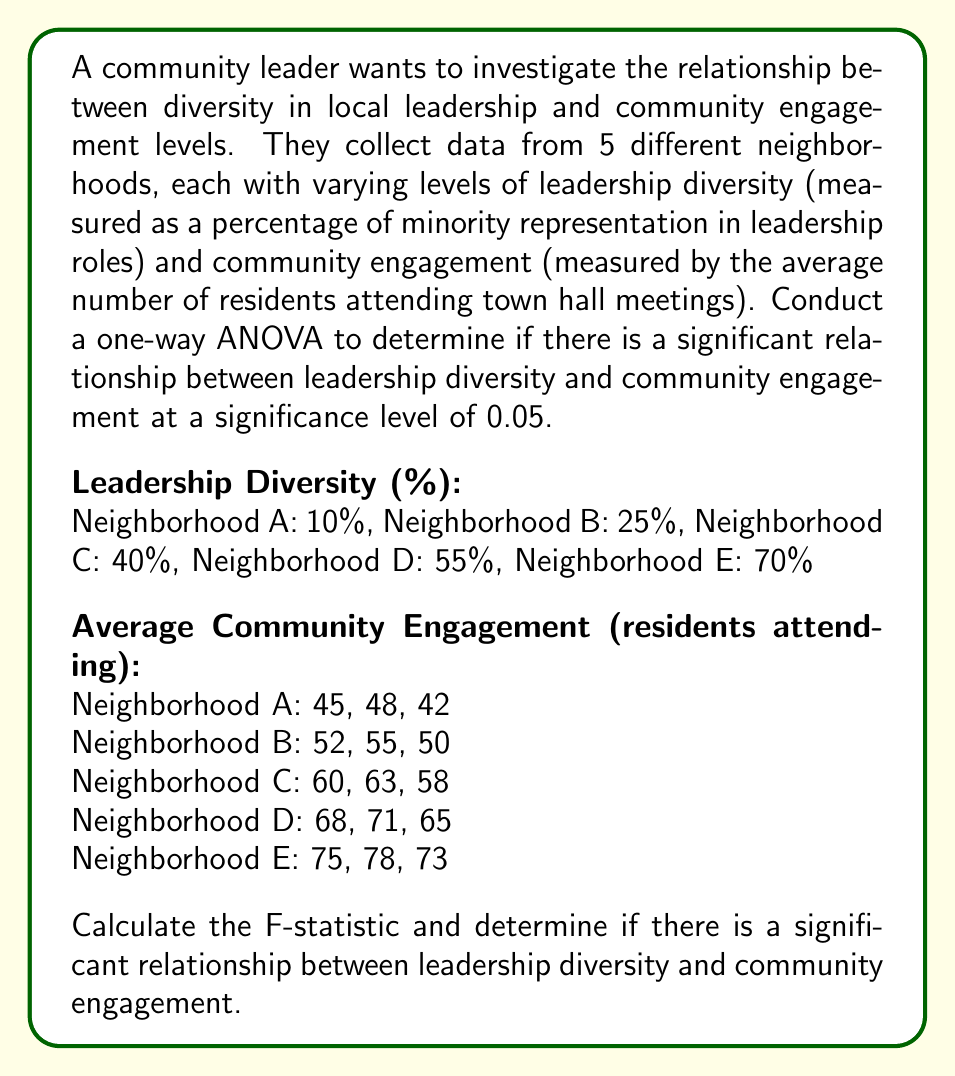Teach me how to tackle this problem. To conduct a one-way ANOVA, we'll follow these steps:

1. Calculate the sum of squares between groups (SSB) and within groups (SSW)
2. Calculate the degrees of freedom between groups (dfB) and within groups (dfW)
3. Calculate the mean square between groups (MSB) and within groups (MSW)
4. Calculate the F-statistic
5. Compare the F-statistic to the critical F-value

Step 1: Calculate SSB and SSW

First, we need to calculate the grand mean:
$$ \bar{X} = \frac{45 + 48 + 42 + 52 + 55 + 50 + 60 + 63 + 58 + 68 + 71 + 65 + 75 + 78 + 73}{15} = 60.2 $$

Now, calculate the group means:
$$ \bar{X}_A = 45, \bar{X}_B = 52.33, \bar{X}_C = 60.33, \bar{X}_D = 68, \bar{X}_E = 75.33 $$

SSB:
$$ SSB = 3[(45 - 60.2)^2 + (52.33 - 60.2)^2 + (60.33 - 60.2)^2 + (68 - 60.2)^2 + (75.33 - 60.2)^2] = 1856.13 $$

SSW:
$$ SSW = [(45-45)^2 + (48-45)^2 + (42-45)^2] + ... + [(75-75.33)^2 + (78-75.33)^2 + (73-75.33)^2] = 126 $$

Step 2: Calculate degrees of freedom

$$ df_B = 5 - 1 = 4 $$
$$ df_W = 15 - 5 = 10 $$

Step 3: Calculate mean squares

$$ MSB = \frac{SSB}{df_B} = \frac{1856.13}{4} = 464.03 $$
$$ MSW = \frac{SSW}{df_W} = \frac{126}{10} = 12.6 $$

Step 4: Calculate F-statistic

$$ F = \frac{MSB}{MSW} = \frac{464.03}{12.6} = 36.83 $$

Step 5: Compare to critical F-value

At a significance level of 0.05, with df_B = 4 and df_W = 10, the critical F-value is approximately 3.48.

Since our calculated F-statistic (36.83) is greater than the critical F-value (3.48), we reject the null hypothesis.
Answer: The F-statistic is 36.83, which is greater than the critical F-value of 3.48 at a significance level of 0.05. Therefore, we conclude that there is a significant relationship between leadership diversity and community engagement levels. 